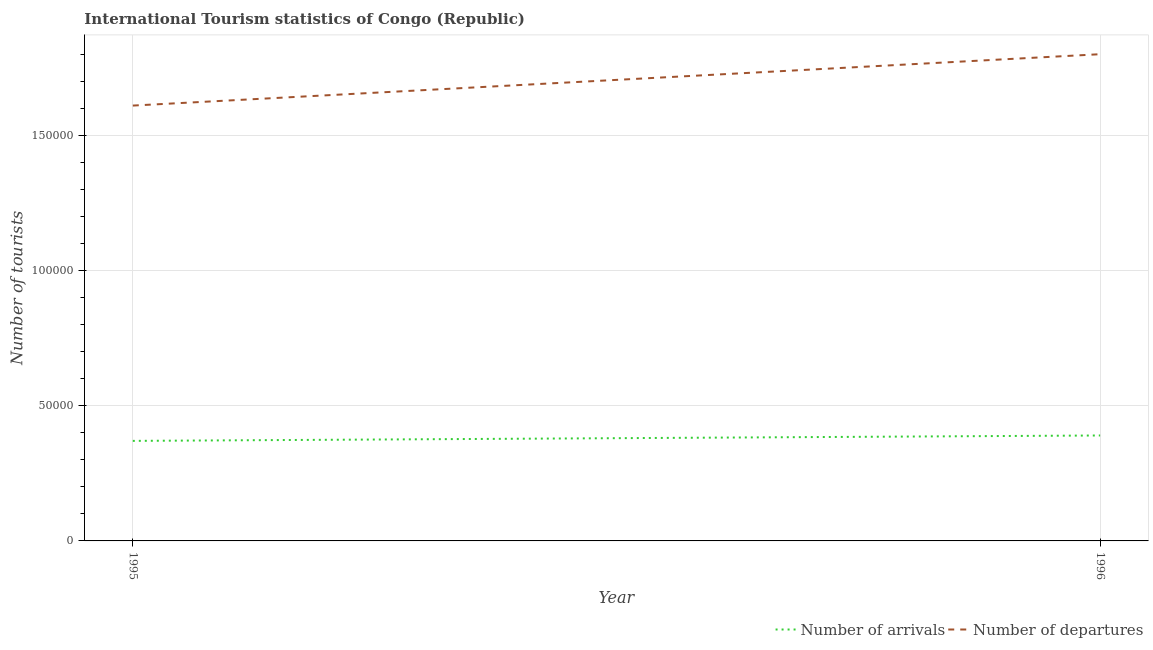What is the number of tourist arrivals in 1996?
Offer a very short reply. 3.90e+04. Across all years, what is the maximum number of tourist departures?
Offer a terse response. 1.80e+05. Across all years, what is the minimum number of tourist departures?
Give a very brief answer. 1.61e+05. In which year was the number of tourist departures minimum?
Offer a very short reply. 1995. What is the total number of tourist departures in the graph?
Your answer should be very brief. 3.41e+05. What is the difference between the number of tourist departures in 1995 and that in 1996?
Provide a succinct answer. -1.90e+04. What is the difference between the number of tourist arrivals in 1996 and the number of tourist departures in 1995?
Your response must be concise. -1.22e+05. What is the average number of tourist arrivals per year?
Offer a very short reply. 3.80e+04. In the year 1996, what is the difference between the number of tourist departures and number of tourist arrivals?
Provide a succinct answer. 1.41e+05. In how many years, is the number of tourist arrivals greater than 90000?
Your answer should be very brief. 0. What is the ratio of the number of tourist arrivals in 1995 to that in 1996?
Make the answer very short. 0.95. Does the number of tourist departures monotonically increase over the years?
Offer a very short reply. Yes. Is the number of tourist arrivals strictly greater than the number of tourist departures over the years?
Provide a succinct answer. No. Does the graph contain any zero values?
Give a very brief answer. No. Does the graph contain grids?
Ensure brevity in your answer.  Yes. How many legend labels are there?
Offer a terse response. 2. How are the legend labels stacked?
Keep it short and to the point. Horizontal. What is the title of the graph?
Offer a very short reply. International Tourism statistics of Congo (Republic). Does "Import" appear as one of the legend labels in the graph?
Ensure brevity in your answer.  No. What is the label or title of the X-axis?
Make the answer very short. Year. What is the label or title of the Y-axis?
Your response must be concise. Number of tourists. What is the Number of tourists in Number of arrivals in 1995?
Make the answer very short. 3.70e+04. What is the Number of tourists of Number of departures in 1995?
Your answer should be compact. 1.61e+05. What is the Number of tourists in Number of arrivals in 1996?
Offer a terse response. 3.90e+04. Across all years, what is the maximum Number of tourists of Number of arrivals?
Your answer should be compact. 3.90e+04. Across all years, what is the maximum Number of tourists in Number of departures?
Give a very brief answer. 1.80e+05. Across all years, what is the minimum Number of tourists in Number of arrivals?
Give a very brief answer. 3.70e+04. Across all years, what is the minimum Number of tourists of Number of departures?
Provide a short and direct response. 1.61e+05. What is the total Number of tourists in Number of arrivals in the graph?
Provide a short and direct response. 7.60e+04. What is the total Number of tourists in Number of departures in the graph?
Provide a succinct answer. 3.41e+05. What is the difference between the Number of tourists of Number of arrivals in 1995 and that in 1996?
Your answer should be compact. -2000. What is the difference between the Number of tourists of Number of departures in 1995 and that in 1996?
Your answer should be compact. -1.90e+04. What is the difference between the Number of tourists of Number of arrivals in 1995 and the Number of tourists of Number of departures in 1996?
Keep it short and to the point. -1.43e+05. What is the average Number of tourists of Number of arrivals per year?
Ensure brevity in your answer.  3.80e+04. What is the average Number of tourists in Number of departures per year?
Make the answer very short. 1.70e+05. In the year 1995, what is the difference between the Number of tourists of Number of arrivals and Number of tourists of Number of departures?
Provide a short and direct response. -1.24e+05. In the year 1996, what is the difference between the Number of tourists of Number of arrivals and Number of tourists of Number of departures?
Give a very brief answer. -1.41e+05. What is the ratio of the Number of tourists of Number of arrivals in 1995 to that in 1996?
Ensure brevity in your answer.  0.95. What is the ratio of the Number of tourists of Number of departures in 1995 to that in 1996?
Give a very brief answer. 0.89. What is the difference between the highest and the second highest Number of tourists of Number of arrivals?
Your answer should be very brief. 2000. What is the difference between the highest and the second highest Number of tourists of Number of departures?
Offer a terse response. 1.90e+04. What is the difference between the highest and the lowest Number of tourists in Number of departures?
Your answer should be compact. 1.90e+04. 